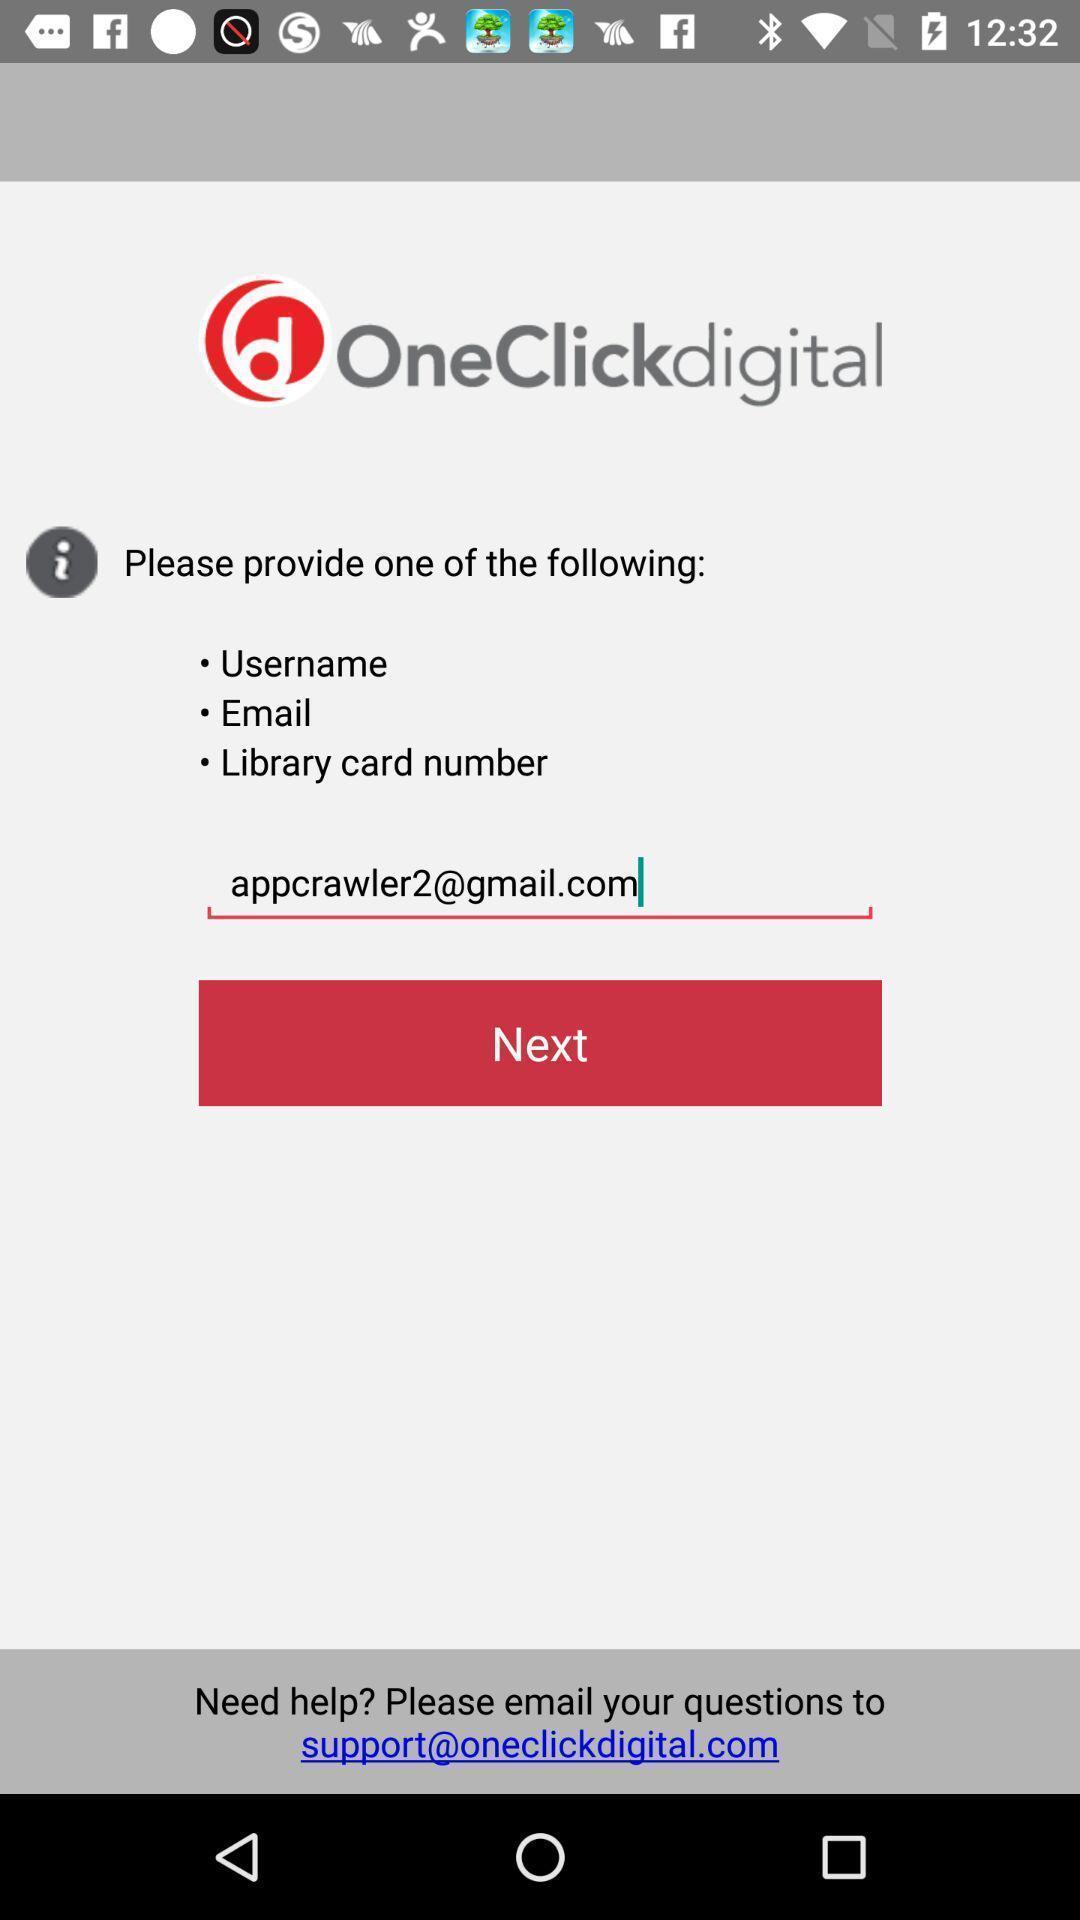Summarize the information in this screenshot. Providing email page of a library app. 